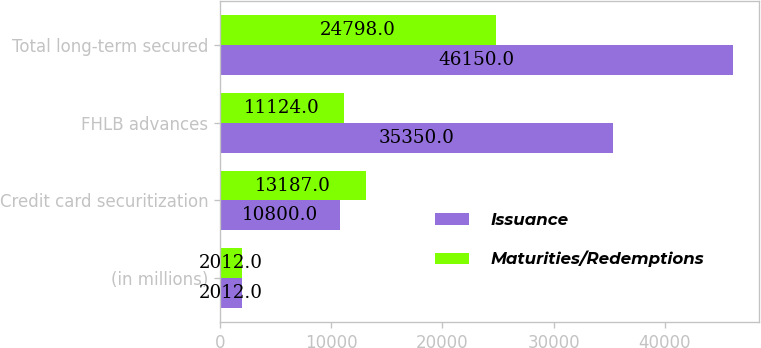Convert chart to OTSL. <chart><loc_0><loc_0><loc_500><loc_500><stacked_bar_chart><ecel><fcel>(in millions)<fcel>Credit card securitization<fcel>FHLB advances<fcel>Total long-term secured<nl><fcel>Issuance<fcel>2012<fcel>10800<fcel>35350<fcel>46150<nl><fcel>Maturities/Redemptions<fcel>2012<fcel>13187<fcel>11124<fcel>24798<nl></chart> 